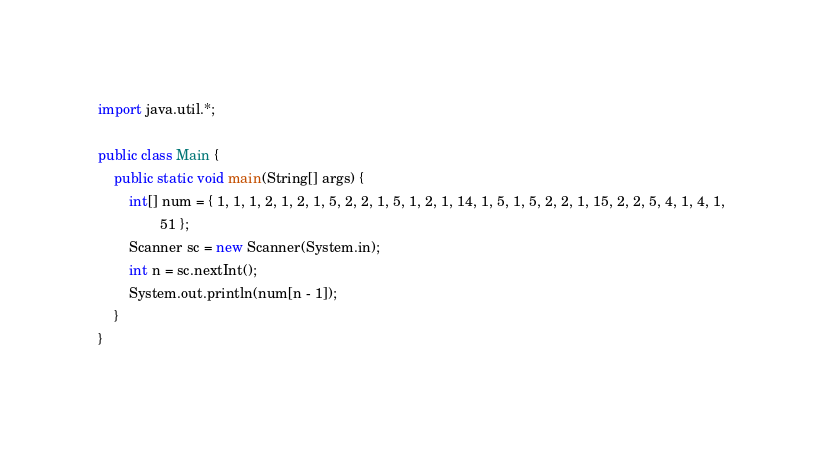<code> <loc_0><loc_0><loc_500><loc_500><_Java_>import java.util.*;

public class Main {
    public static void main(String[] args) {
        int[] num = { 1, 1, 1, 2, 1, 2, 1, 5, 2, 2, 1, 5, 1, 2, 1, 14, 1, 5, 1, 5, 2, 2, 1, 15, 2, 2, 5, 4, 1, 4, 1,
                51 };
        Scanner sc = new Scanner(System.in);
        int n = sc.nextInt();
        System.out.println(num[n - 1]);
    }
}</code> 